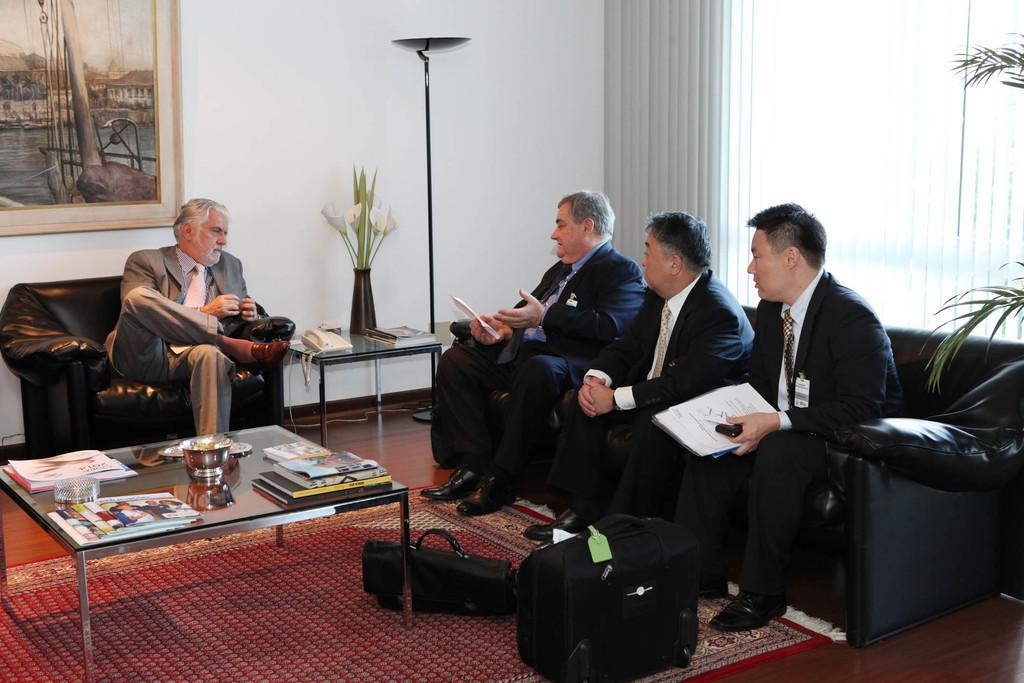Can you describe this image briefly? In the image we can see there are people who are sitting on sofa and on chair. On the table there are books, paper and a bowl. 